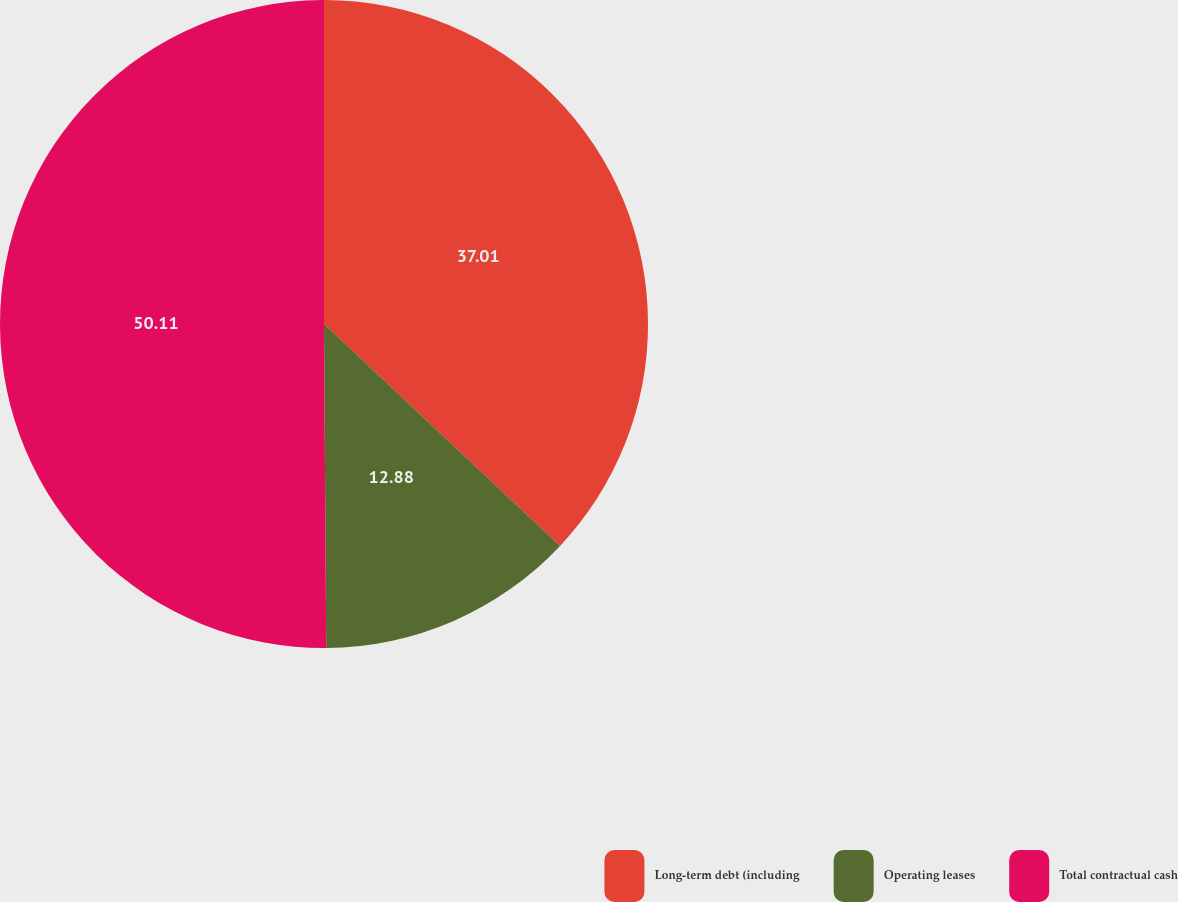<chart> <loc_0><loc_0><loc_500><loc_500><pie_chart><fcel>Long-term debt (including<fcel>Operating leases<fcel>Total contractual cash<nl><fcel>37.01%<fcel>12.88%<fcel>50.11%<nl></chart> 